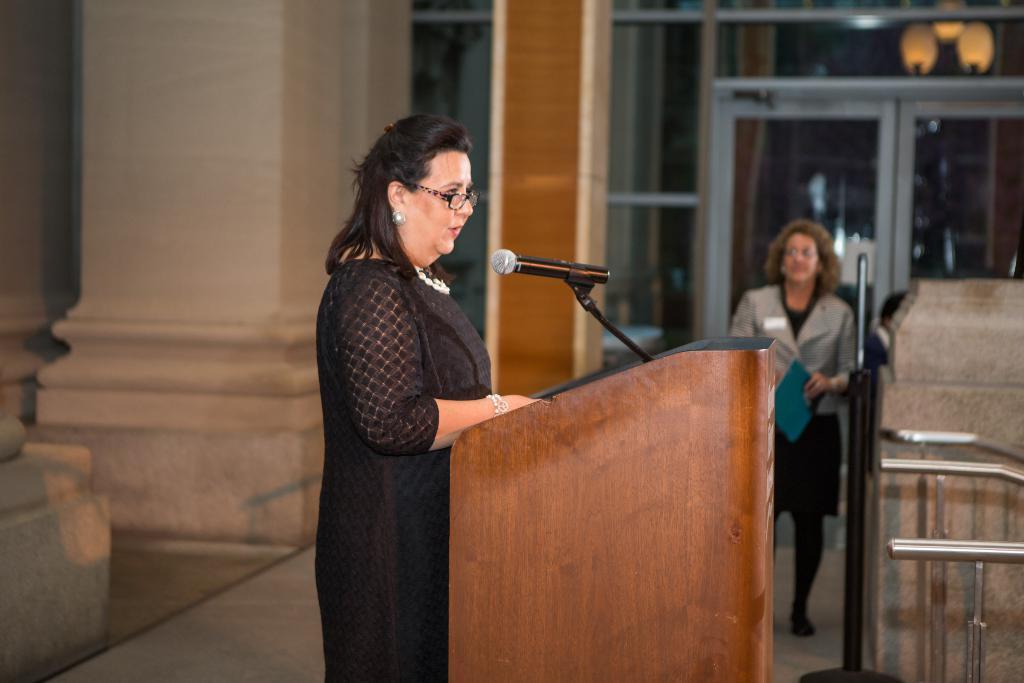How would you summarize this image in a sentence or two? In this image there is a women standing at the podium and she is talking, there is an other women standing and she is listening. At the left side of the image there are two pillars and at the back side there is a door. There is a microphone on the podium. 